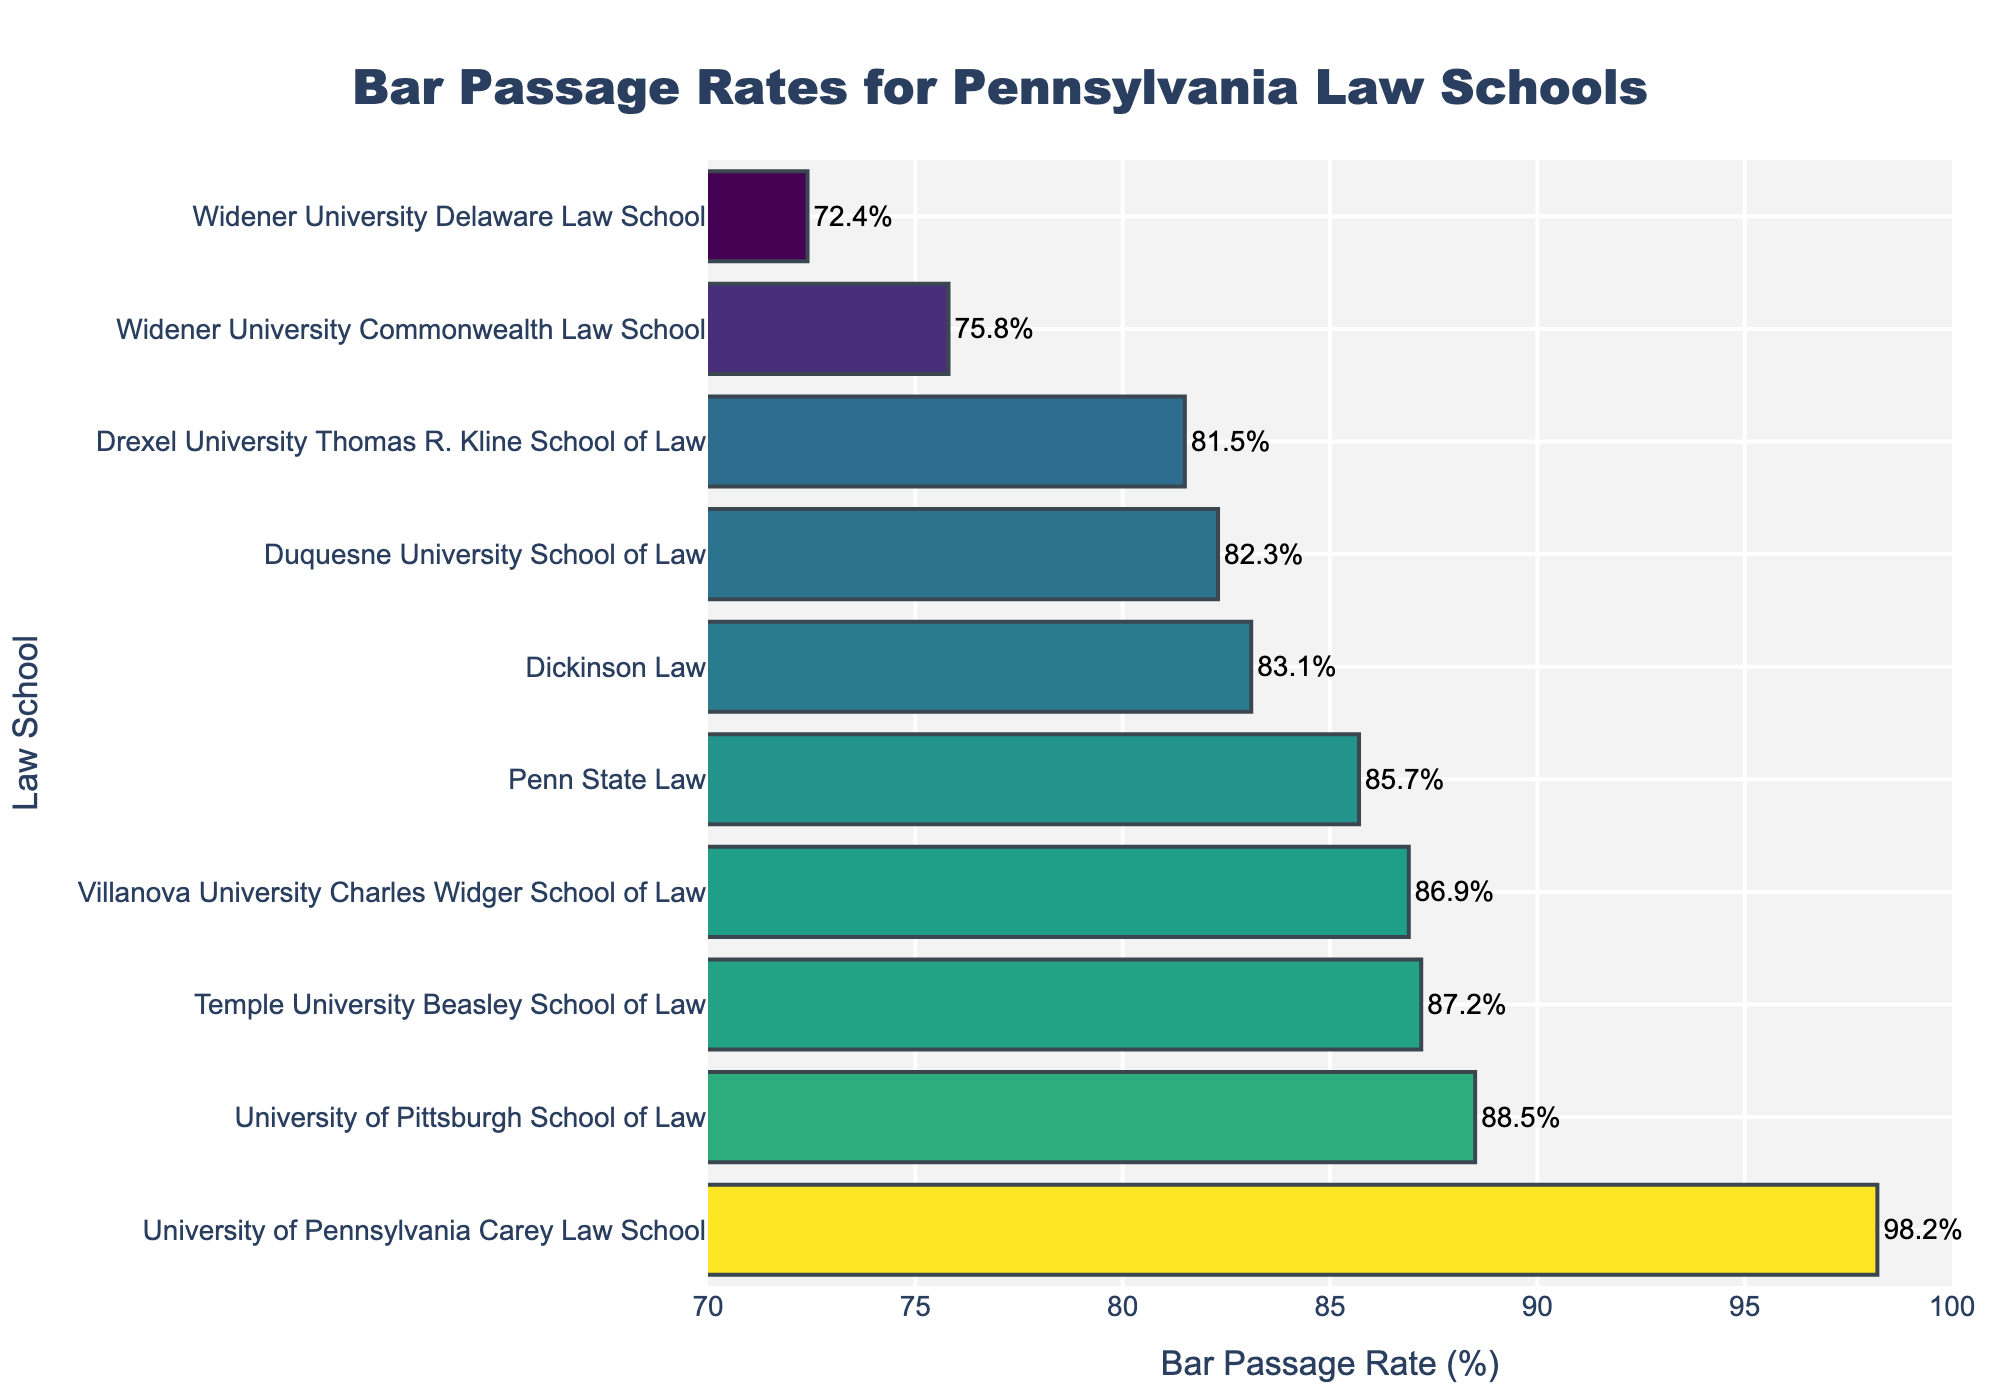What is the bar passage rate of the University of Pittsburgh School of Law? Look at the bar labeled "University of Pittsburgh School of Law" and read the value next to it.
Answer: 88.5% Which school has the lowest bar passage rate? Identify the shortest bar in the chart, which corresponds to the school with the lowest bar passage rate.
Answer: Widener University Delaware Law School How much higher is the bar passage rate of the University of Pennsylvania Carey Law School compared to Penn State Law? Find the bar passage rates of the University of Pennsylvania Carey Law School (98.2) and Penn State Law (85.7). Subtract the latter from the former (98.2 - 85.7).
Answer: 12.5 Rank the schools from highest to lowest bar passage rate. Look at the lengths of the bars from longest to shortest and note the corresponding school names in that order.
Answer: University of Pennsylvania Carey Law School, University of Pittsburgh School of Law, Temple University Beasley School of Law, Villanova University Charles Widger School of Law, Penn State Law, Dickinson Law, Duquesne University School of Law, Drexel University Thomas R. Kline School of Law, Widener University Commonwealth Law School, Widener University Delaware Law School What is the average bar passage rate of all the schools? Add the bar passage rates of all schools and divide by the number of schools. (88.5 + 82.3 + 85.7 + 87.2 + 86.9 + 81.5 + 75.8 + 98.2 + 83.1 + 72.4) / 10 = 84.16
Answer: 84.16 Which two schools have the closest bar passage rates? Identify pairs of schools whose bars have the closest lengths. Compare their rates to find the smallest difference.
Answer: Temple University Beasley School of Law and Villanova University Charles Widger School of Law What is the difference between the highest and the lowest bar passage rates? Identify the highest (University of Pennsylvania Carey Law School, 98.2) and lowest (Widener University Delaware Law School, 72.4) bar passage rates and subtract the lowest from the highest (98.2 - 72.4).
Answer: 25.8 How many schools have a bar passage rate above 85%? Count the number of bars with values greater than 85%.
Answer: 5 Which school is immediately below the University of Pittsburgh School of Law in terms of bar passage rate? Locate the University of Pittsburgh School of Law's bar and identify the bar immediately below it.
Answer: Temple University Beasley School of Law 